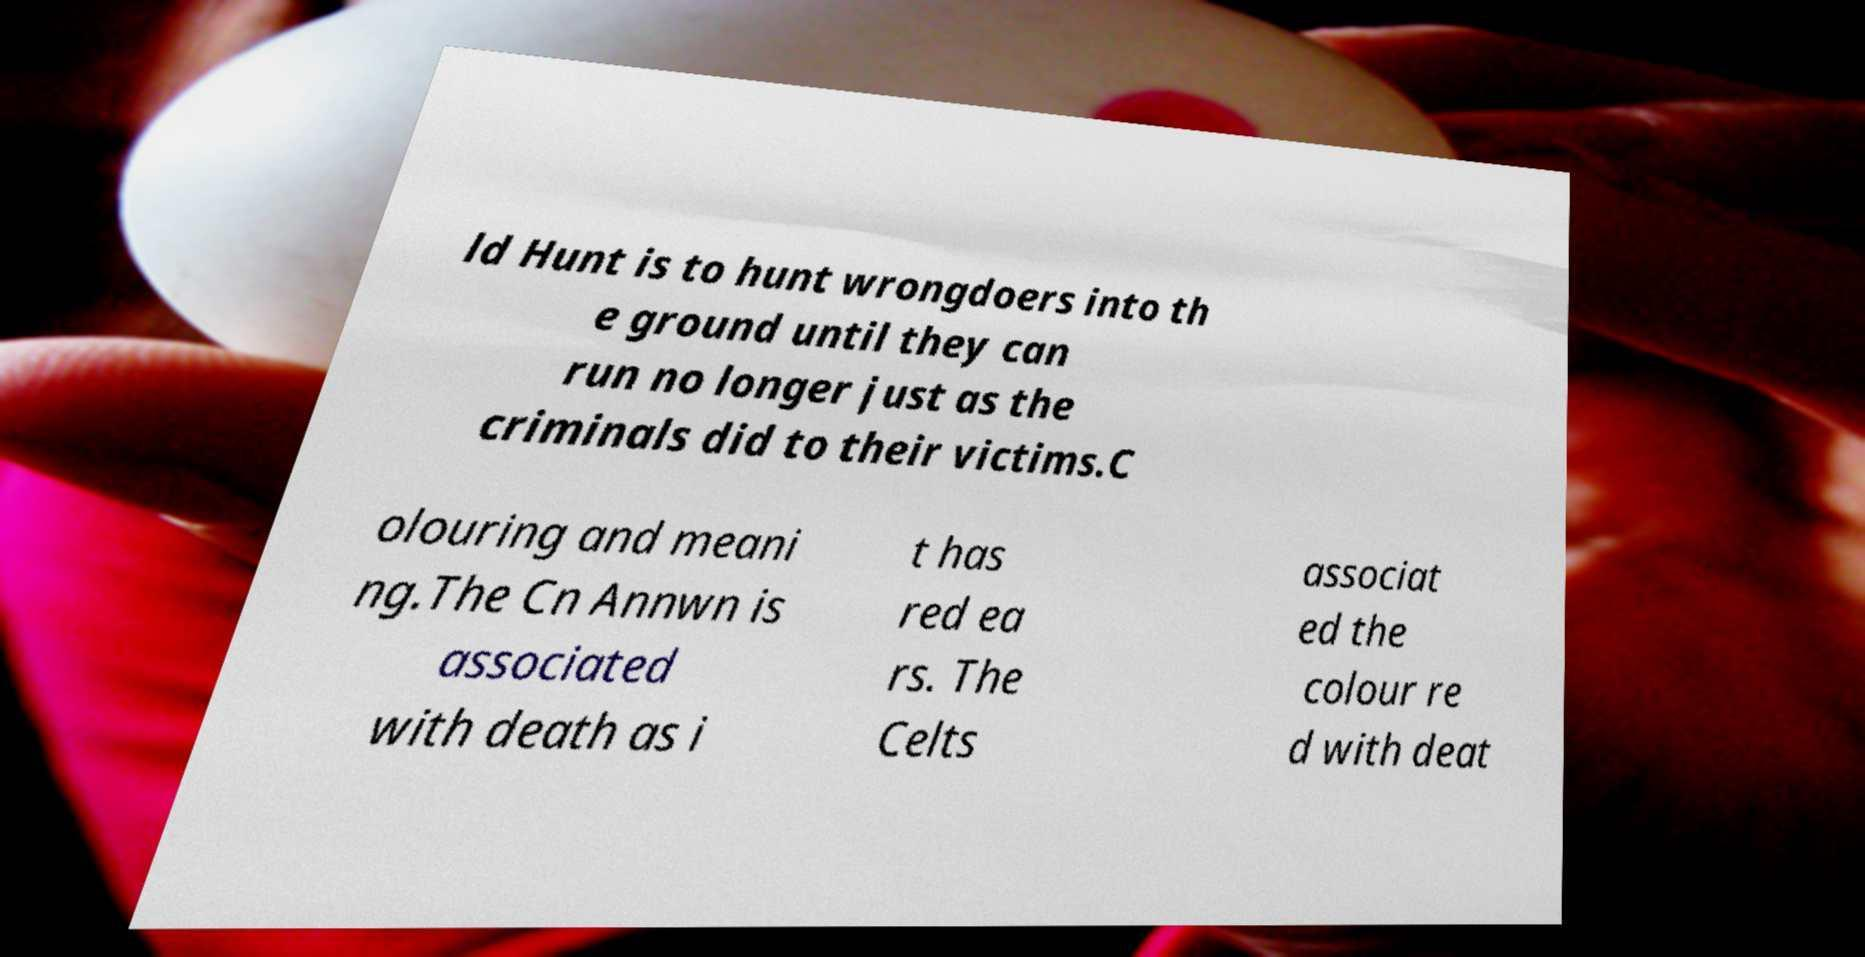Please read and relay the text visible in this image. What does it say? ld Hunt is to hunt wrongdoers into th e ground until they can run no longer just as the criminals did to their victims.C olouring and meani ng.The Cn Annwn is associated with death as i t has red ea rs. The Celts associat ed the colour re d with deat 